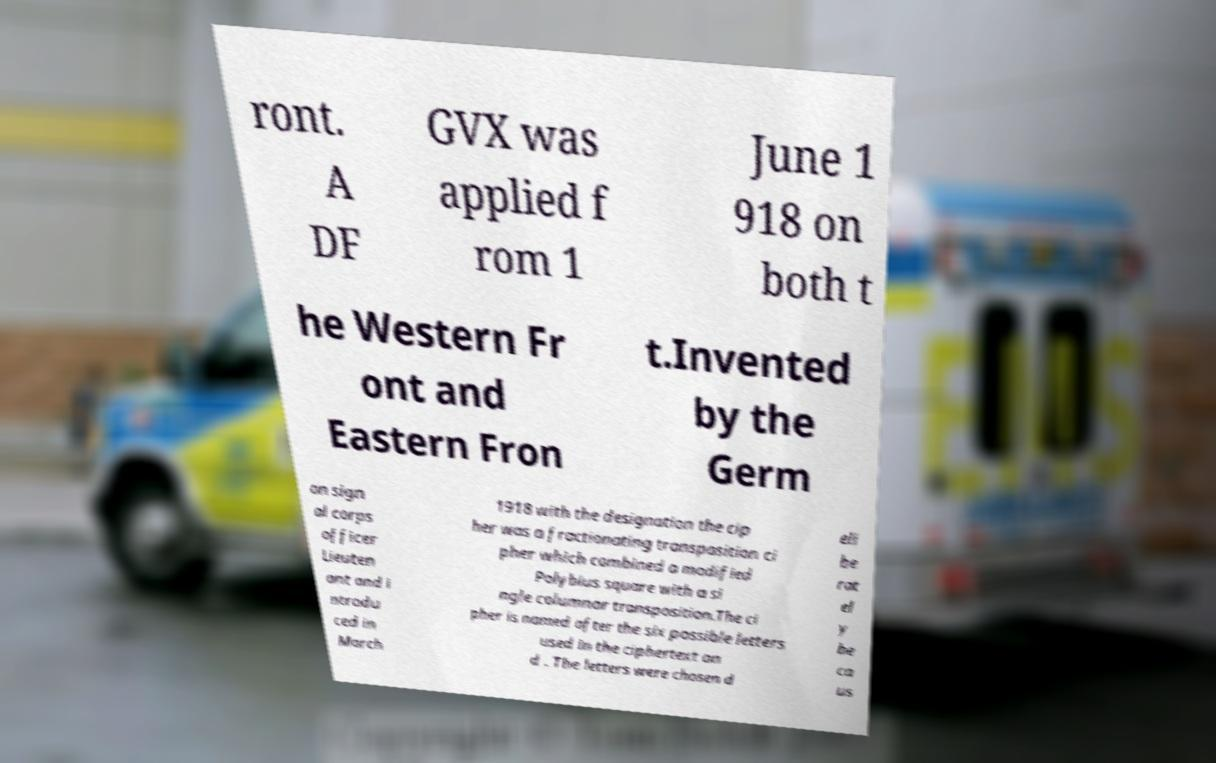There's text embedded in this image that I need extracted. Can you transcribe it verbatim? ront. A DF GVX was applied f rom 1 June 1 918 on both t he Western Fr ont and Eastern Fron t.Invented by the Germ an sign al corps officer Lieuten ant and i ntrodu ced in March 1918 with the designation the cip her was a fractionating transposition ci pher which combined a modified Polybius square with a si ngle columnar transposition.The ci pher is named after the six possible letters used in the ciphertext an d . The letters were chosen d eli be rat el y be ca us 